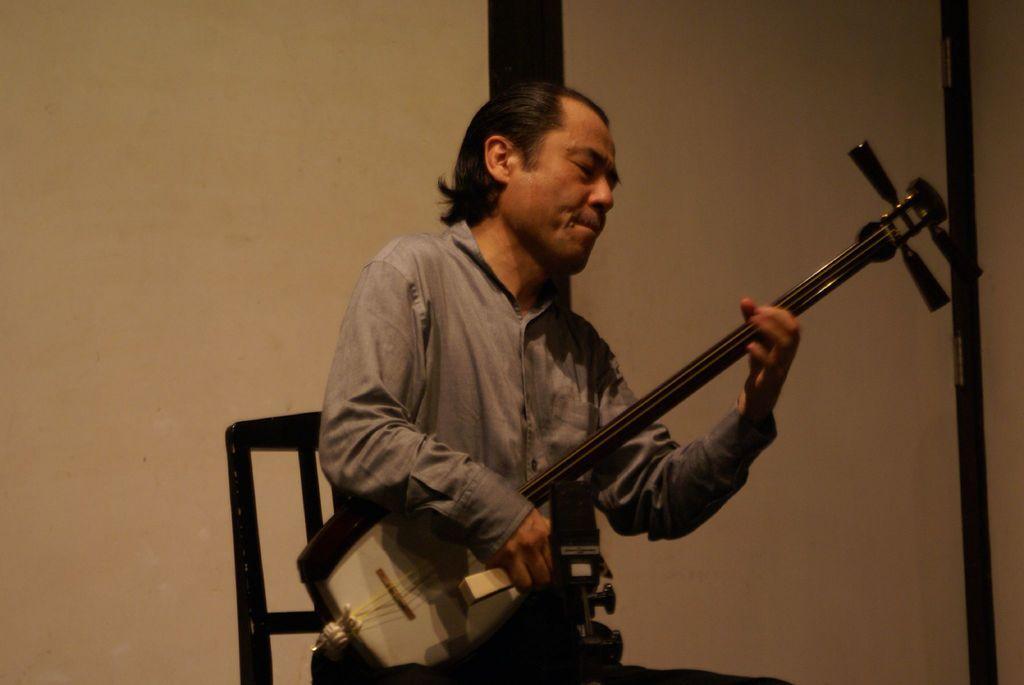How would you summarize this image in a sentence or two? In the background we can see the wall and it looks like a door. In this picture we can see a man sitting on a chair and he is playing a musical instrument. 